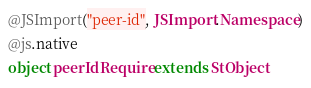<code> <loc_0><loc_0><loc_500><loc_500><_Scala_>@JSImport("peer-id", JSImport.Namespace)
@js.native
object peerIdRequire extends StObject
</code> 